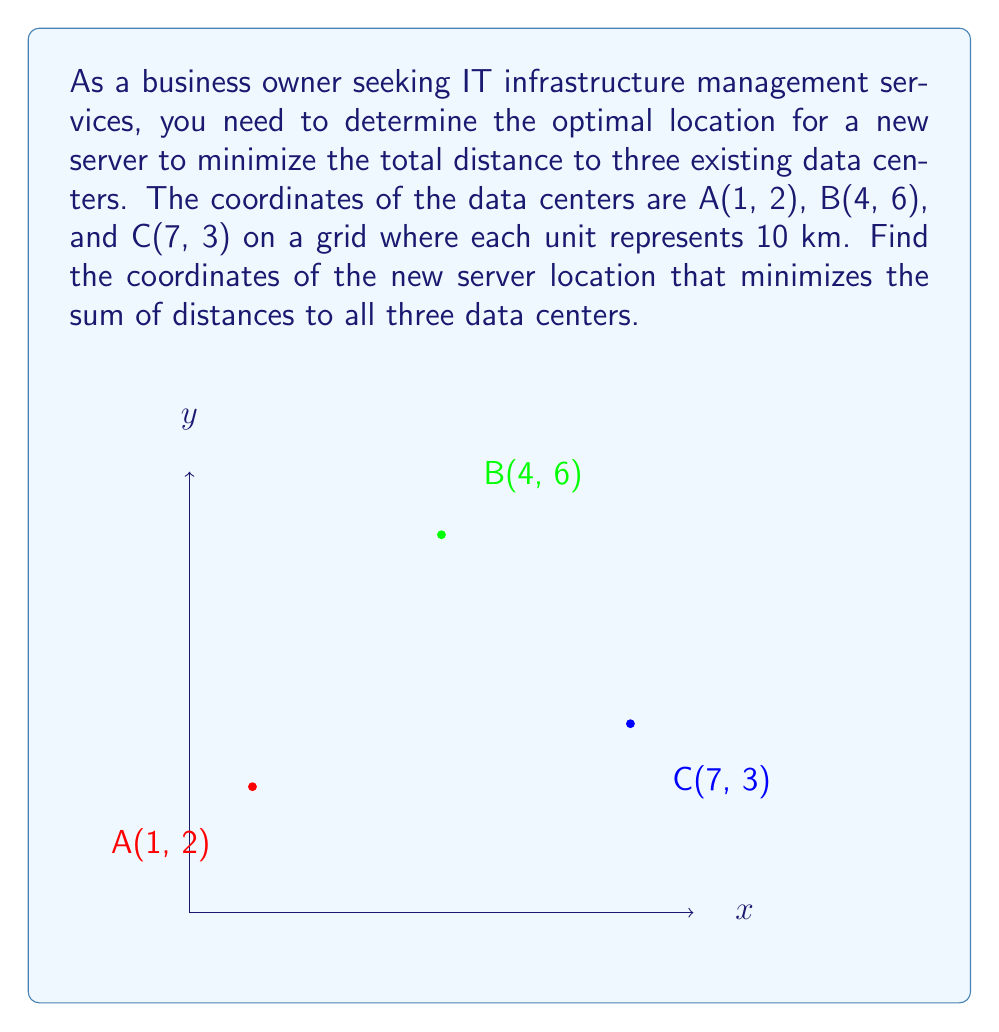Could you help me with this problem? To find the optimal server location, we'll use the concept of the geometric median, also known as the Fermat point. For this problem, we'll use an approximation method called the Weiszfeld algorithm.

Step 1: Initialize the starting point as the centroid of the triangle formed by the three data centers.
$$ x_0 = \frac{1 + 4 + 7}{3} = 4, \quad y_0 = \frac{2 + 6 + 3}{3} = \frac{11}{3} $$

Step 2: Apply the Weiszfeld algorithm iteratively:
$$ x_{n+1} = \frac{\sum_{i=1}^3 \frac{x_i}{d_i}}{\sum_{i=1}^3 \frac{1}{d_i}}, \quad y_{n+1} = \frac{\sum_{i=1}^3 \frac{y_i}{d_i}}{\sum_{i=1}^3 \frac{1}{d_i}} $$
where $(x_i, y_i)$ are the coordinates of each data center, and $d_i$ is the distance from the current point to each data center.

Step 3: Calculate distances and update coordinates (showing first iteration):
$$ d_1 = \sqrt{(4-1)^2 + (\frac{11}{3}-2)^2} \approx 3.6056 $$
$$ d_2 = \sqrt{(4-4)^2 + (\frac{11}{3}-6)^2} \approx 2.4495 $$
$$ d_3 = \sqrt{(4-7)^2 + (\frac{11}{3}-3)^2} \approx 3.6056 $$

$$ x_1 = \frac{\frac{1}{3.6056} + \frac{4}{2.4495} + \frac{7}{3.6056}}{\frac{1}{3.6056} + \frac{1}{2.4495} + \frac{1}{3.6056}} \approx 3.9687 $$
$$ y_1 = \frac{\frac{2}{3.6056} + \frac{6}{2.4495} + \frac{3}{3.6056}}{\frac{1}{3.6056} + \frac{1}{2.4495} + \frac{1}{3.6056}} \approx 3.8438 $$

Step 4: Repeat the process until the change in coordinates is negligible (usually 3-4 iterations).

Step 5: Round the final coordinates to two decimal places for practical implementation.
Answer: (3.97, 3.84) 